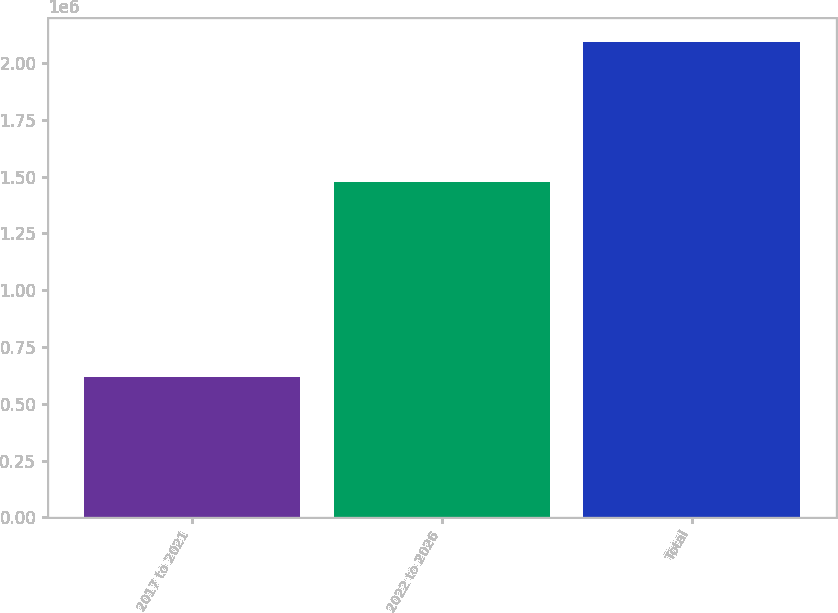<chart> <loc_0><loc_0><loc_500><loc_500><bar_chart><fcel>2017 to 2021<fcel>2022 to 2026<fcel>Total<nl><fcel>617039<fcel>1.47664e+06<fcel>2.09368e+06<nl></chart> 